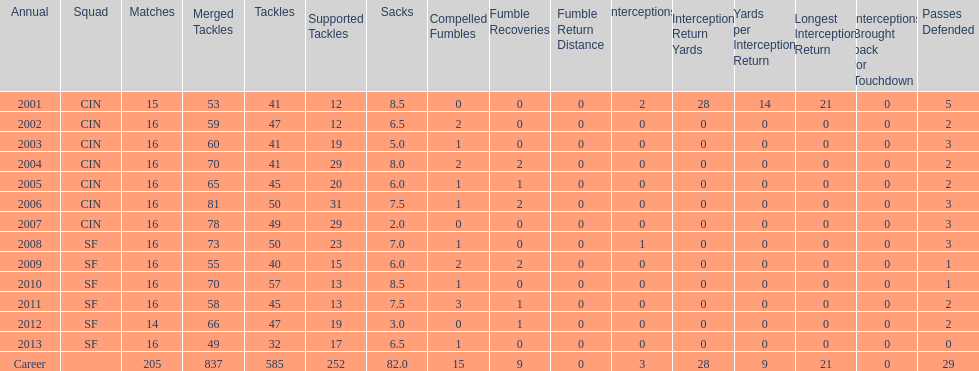How many consecutive years were there 20 or more assisted tackles? 5. 